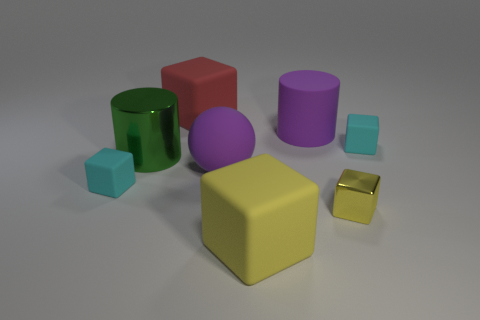Are there any tiny metal cubes of the same color as the sphere?
Offer a very short reply. No. Are there the same number of small metallic blocks that are behind the tiny yellow shiny cube and tiny cyan objects on the right side of the big red matte thing?
Provide a short and direct response. No. There is a large red matte object; is its shape the same as the cyan object that is left of the small shiny cube?
Your answer should be compact. Yes. How many other objects are there of the same material as the tiny yellow object?
Give a very brief answer. 1. Are there any large matte cylinders to the left of the large yellow matte object?
Offer a very short reply. No. Is the size of the metallic cube the same as the purple thing that is in front of the large purple rubber cylinder?
Your answer should be compact. No. There is a shiny thing in front of the tiny block that is left of the large green metallic object; what color is it?
Your response must be concise. Yellow. Is the purple sphere the same size as the green shiny object?
Keep it short and to the point. Yes. There is a cube that is both behind the shiny cylinder and on the right side of the large rubber cylinder; what is its color?
Offer a terse response. Cyan. The yellow matte thing is what size?
Your answer should be compact. Large. 